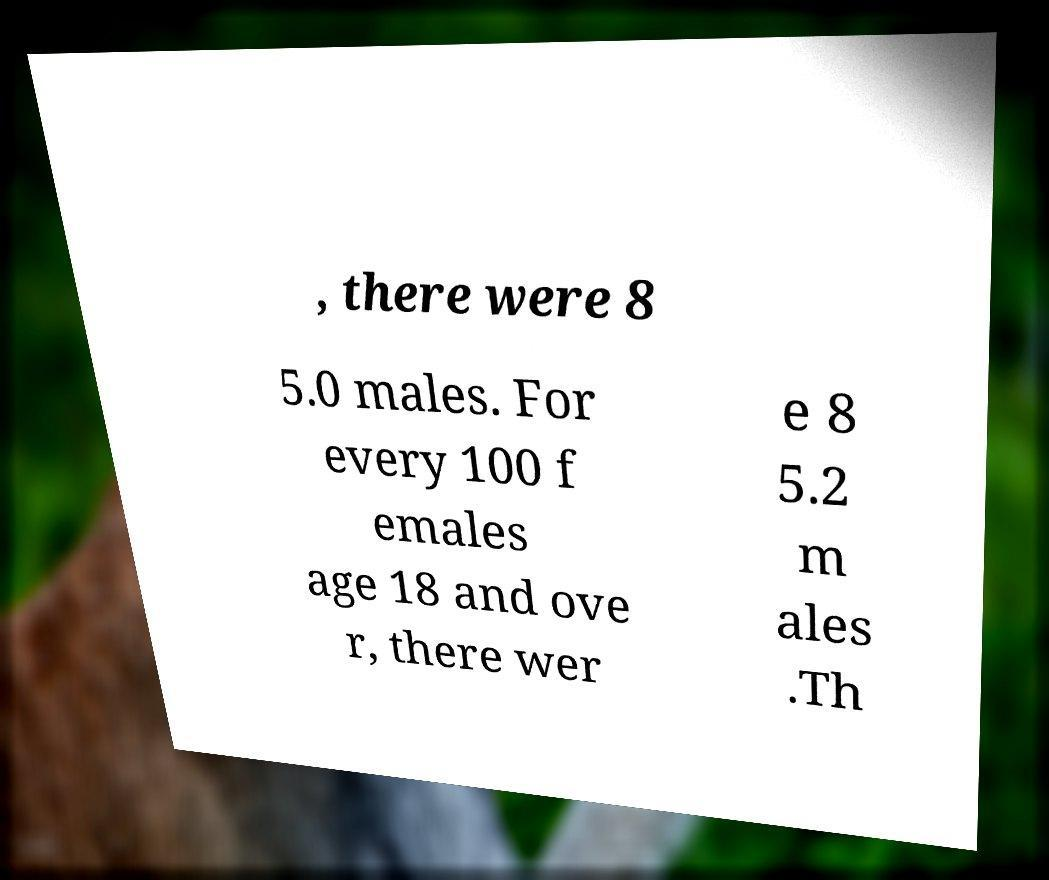Can you accurately transcribe the text from the provided image for me? , there were 8 5.0 males. For every 100 f emales age 18 and ove r, there wer e 8 5.2 m ales .Th 